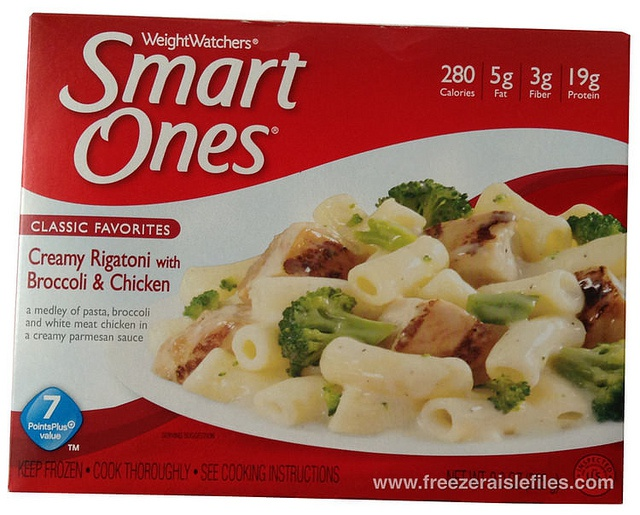Describe the objects in this image and their specific colors. I can see broccoli in white, olive, and darkgreen tones, broccoli in white, olive, black, and gray tones, broccoli in white, darkgreen, and darkgray tones, broccoli in white, olive, and black tones, and broccoli in white, olive, darkgreen, and black tones in this image. 